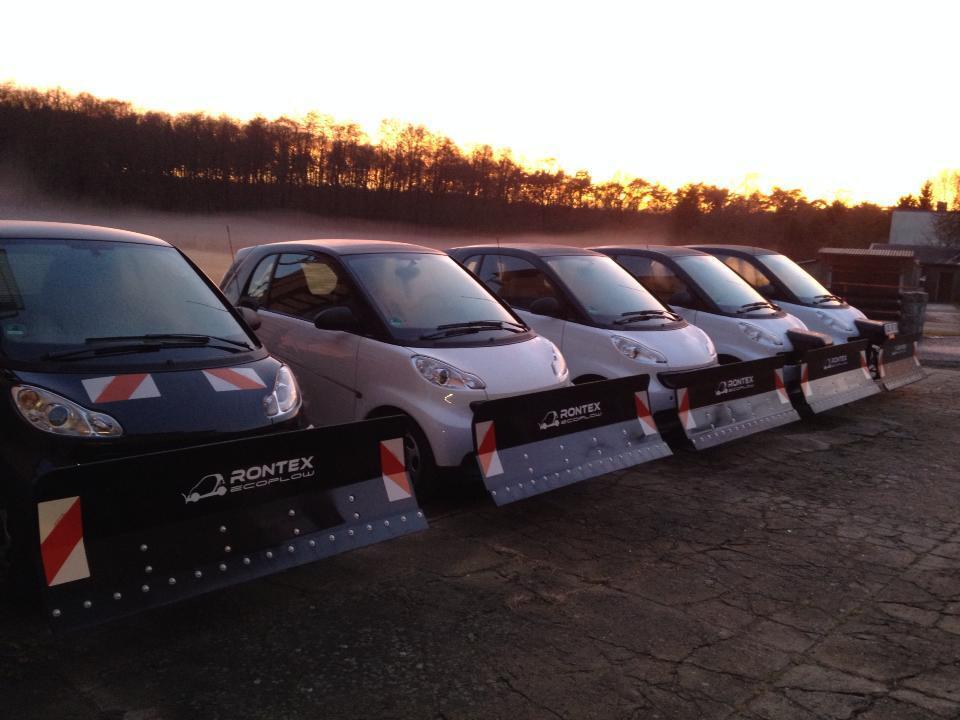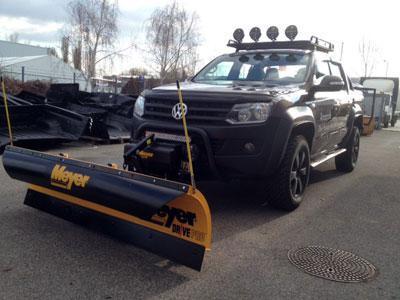The first image is the image on the left, the second image is the image on the right. Analyze the images presented: Is the assertion "An image shows a smart-car shaped orange vehicle with a plow attachment." valid? Answer yes or no. No. 